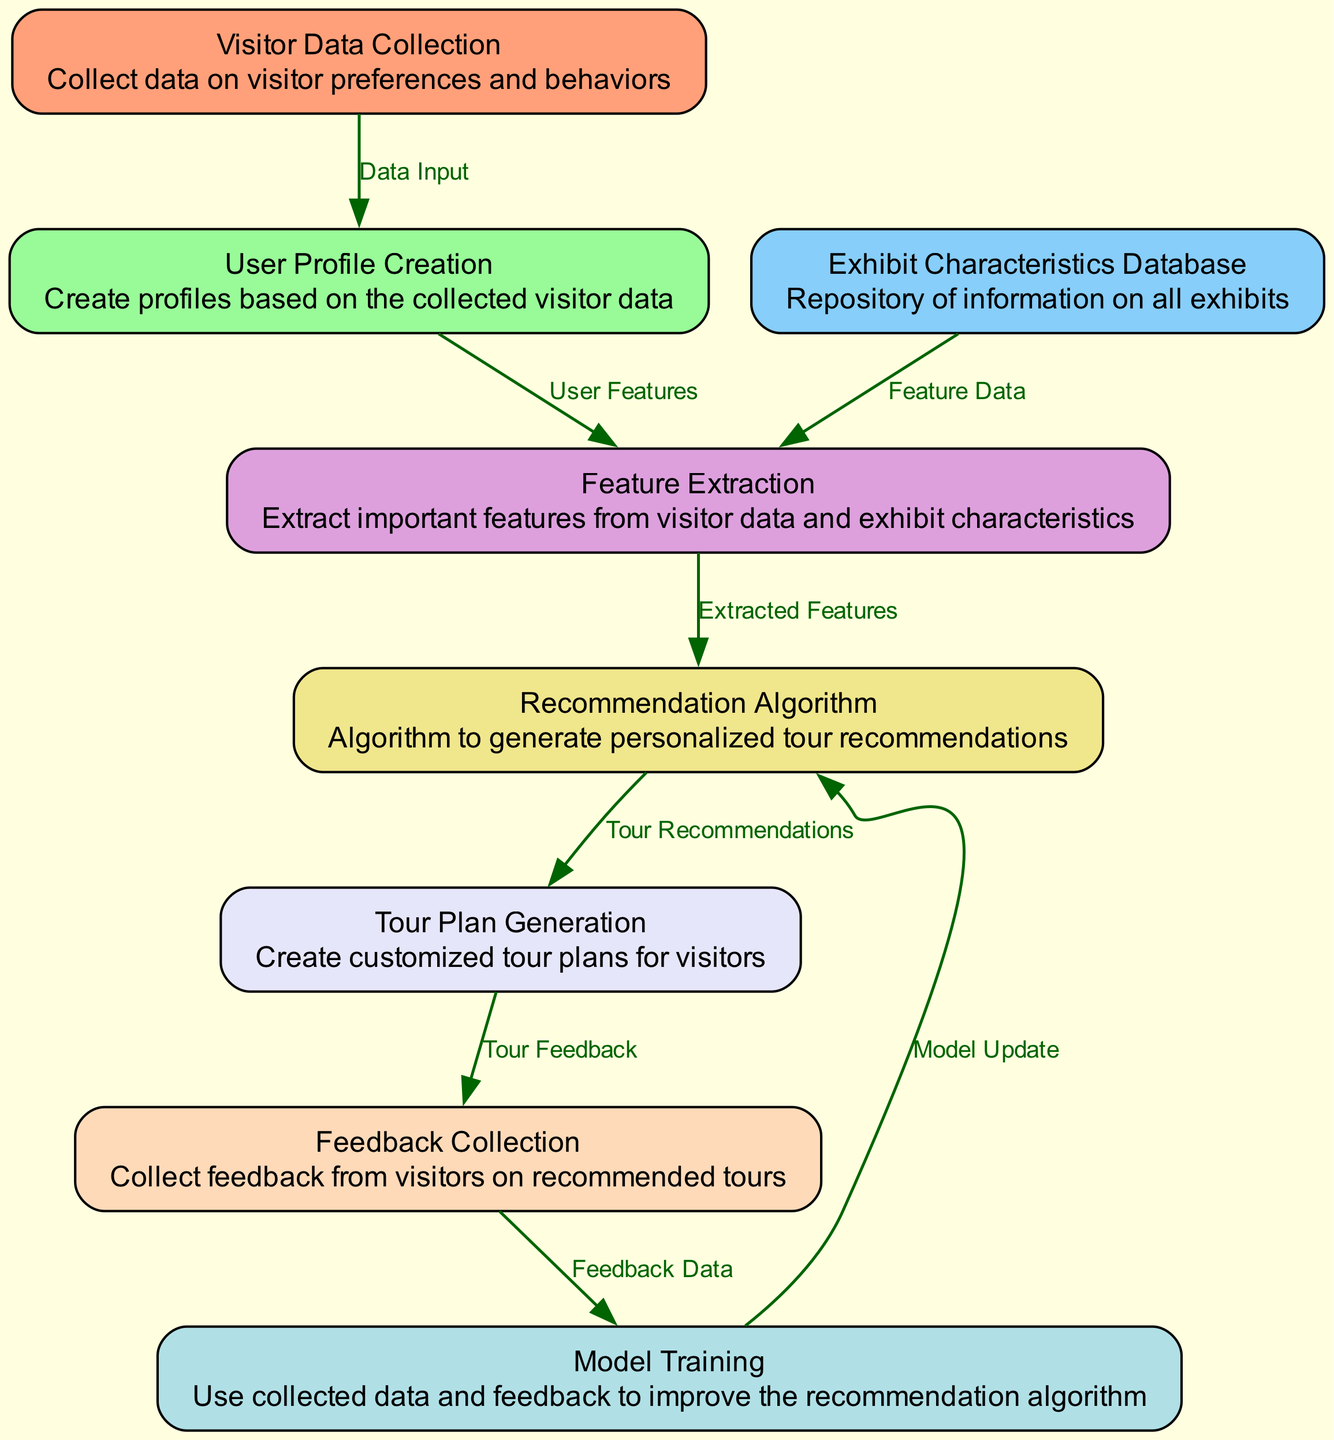What is the first node in the diagram? The first node listed in the data is "Visitor Data Collection". This node is positioned at the top of the diagram as it is the initial step in the process, collecting data on visitor preferences and behaviors.
Answer: Visitor Data Collection How many nodes are present in the diagram? The diagram contains a total of 8 nodes as detailed in the data. Each node represents a distinct function within the personalized recommendation system.
Answer: 8 What is the relationship between "Recommendation Algorithm" and "Tour Plan Generation"? The relationship is indicated by a directed edge where "Recommendation Algorithm" points to "Tour Plan Generation," labeled "Tour Recommendations." This means that the recommendation algorithm generates input for creating customized tour plans.
Answer: Tour Recommendations Which node provides data for "Feature Extraction"? The "Exhibit Characteristics Database" node provides "Feature Data" for the "Feature Extraction" node as indicated by the directed edge linking them. This allows important traits of the exhibits to be identified for making recommendations.
Answer: Exhibit Characteristics Database What type of data is collected in the "Feedback Collection" node? The "Feedback Collection" node gathers data labeled as "Tour Feedback," which is used to assess the effectiveness of the recommended tours received by visitors and their satisfaction ratings.
Answer: Tour Feedback What process follows after "Feedback Collection"? After "Feedback Collection," the next step is "Model Training," where the system uses the feedback data to improve the recommendation algorithm through learning and adjustment based on user experiences.
Answer: Model Training What links "User Profile Creation" to "Feature Extraction"? The edge labeled "User Features" connects "User Profile Creation" to "Feature Extraction." This indicates that user profiles contain features that are extracted to inform the recommendation algorithm.
Answer: User Features Which node is the last in the sequence? The last node in the sequence is "Recommendation Algorithm." This node gathers input from the previous steps and outputs personalized tour recommendations for visitors, completing the flow of the process.
Answer: Recommendation Algorithm 